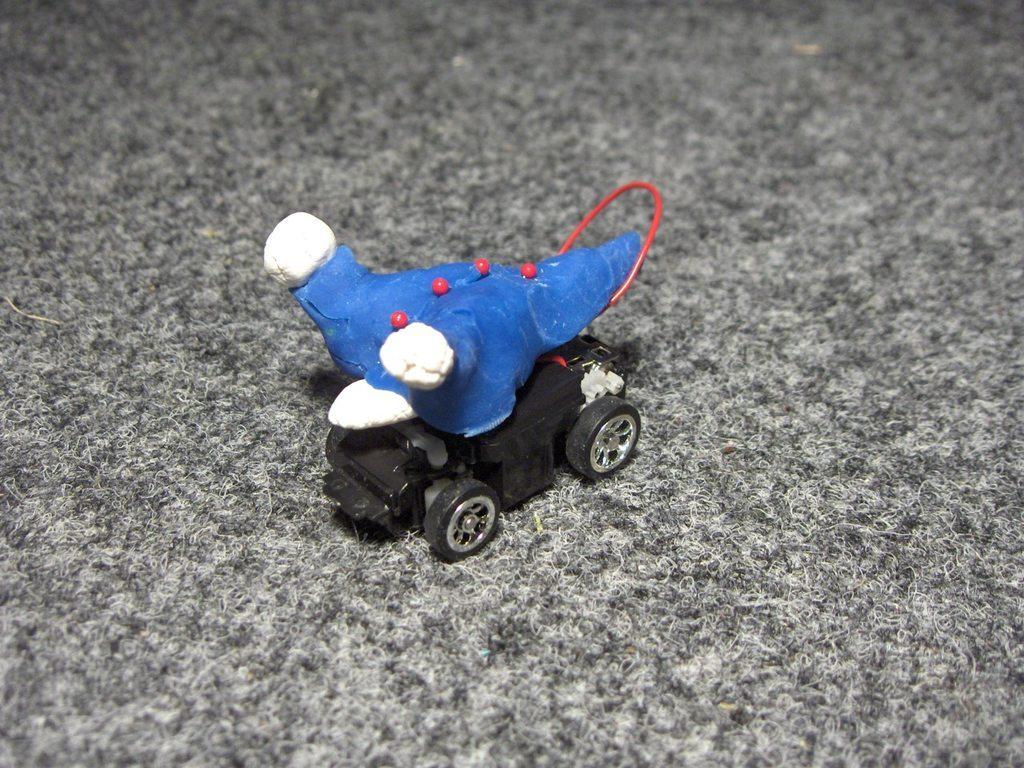Please provide a concise description of this image. In this image in the center there is one toy, at the bottom there is carpet. 